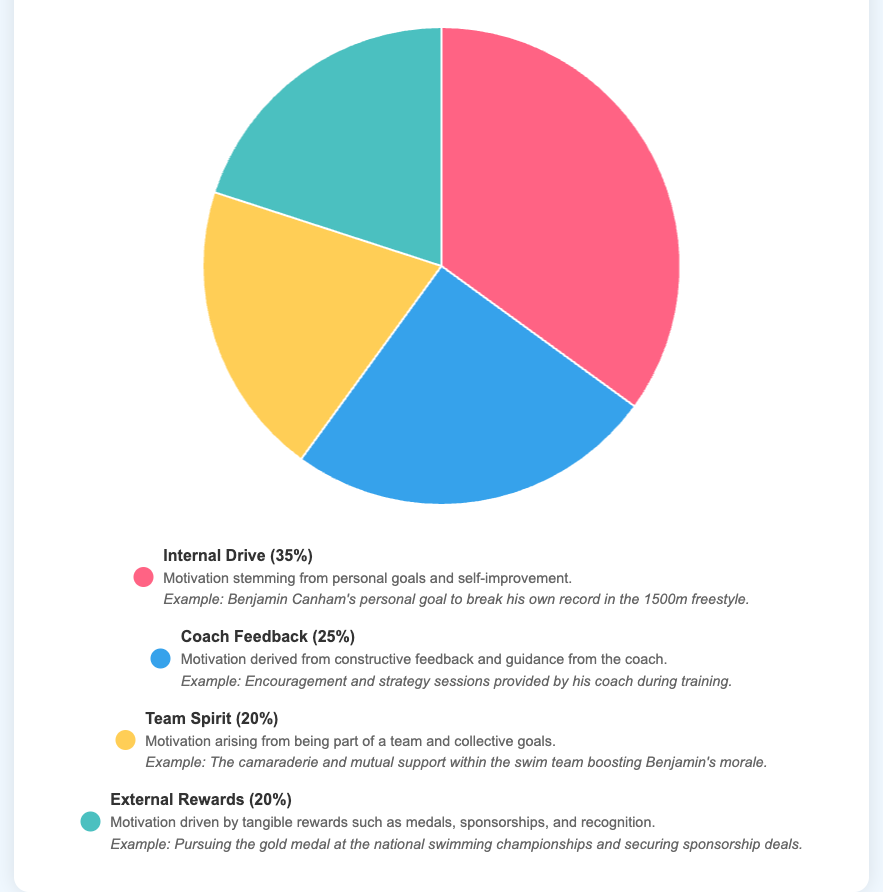What is the largest source of motivation among athletes in the dataset? The largest source of motivation is identified by finding the highest percentage value among the data points. Internal Drive has a percentage of 35%, which is higher than the other sources.
Answer: Internal Drive Which two sources of motivation make up an equal percentage of the total motivation pie chart? To find the sources with equal percentages, compare the percentage values of all data points. Both Team Spirit and External Rewards have a percentage of 20%.
Answer: Team Spirit, External Rewards What is the percentage difference between Internal Drive and Coach Feedback? Subtract the percentage of Coach Feedback from the percentage of Internal Drive. The difference is 35% - 25% = 10%.
Answer: 10% If we combine the percentages of Team Spirit and External Rewards, what fraction of the total motivation does this represent? Add the percentages of Team Spirit and External Rewards: 20% + 20% = 40%.
Answer: 40% How much more motivation does Coach Feedback provide compared to Team Spirit? Subtract the percentage of Team Spirit from the percentage of Coach Feedback: 25% - 20% = 5%.
Answer: 5% Which source of motivation corresponds to the blue color in the pie chart? Look at the legend or the chart to determine which segment of the pie chart is blue. The blue section corresponds to Coach Feedback.
Answer: Coach Feedback What is the sum of the percentages for the two least contributing sources of motivation? Identify the two smallest percentages: Team Spirit (20%) and External Rewards (20%). Their sum is 20% + 20% = 40%.
Answer: 40% How many sources of motivation have a percentage value lower than Internal Drive? Compare each source's percentage to that of Internal Drive (35%). Coach Feedback (25%), Team Spirit (20%), and External Rewards (20%) are all lower. Thus, there are 3 sources.
Answer: 3 Which source of motivation is represented by the red color in the pie chart? Refer to the legend or visual attributes of the chart to determine which segment is red. The red segment corresponds to Internal Drive.
Answer: Internal Drive Considering all the sources together, what is their average percentage contribution to motivation? Add all percentages: 35% + 25% + 20% + 20% = 100%. Divide by the number of sources (4): 100% / 4 = 25%.
Answer: 25% 